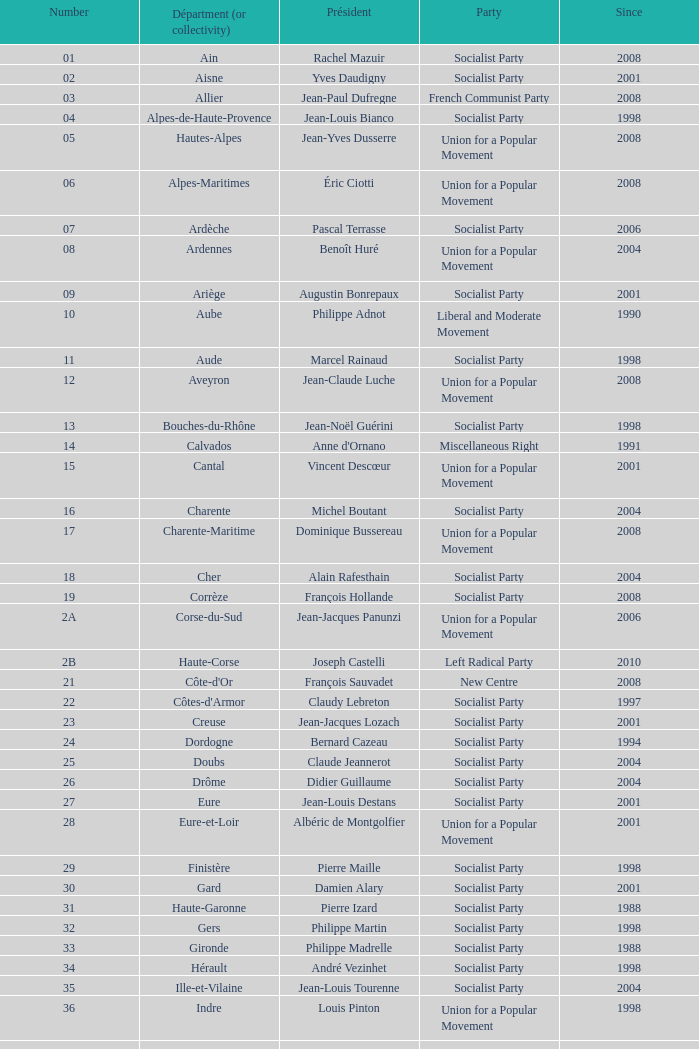What figure corresponds to president yves krattinger of the socialist party? 70.0. 